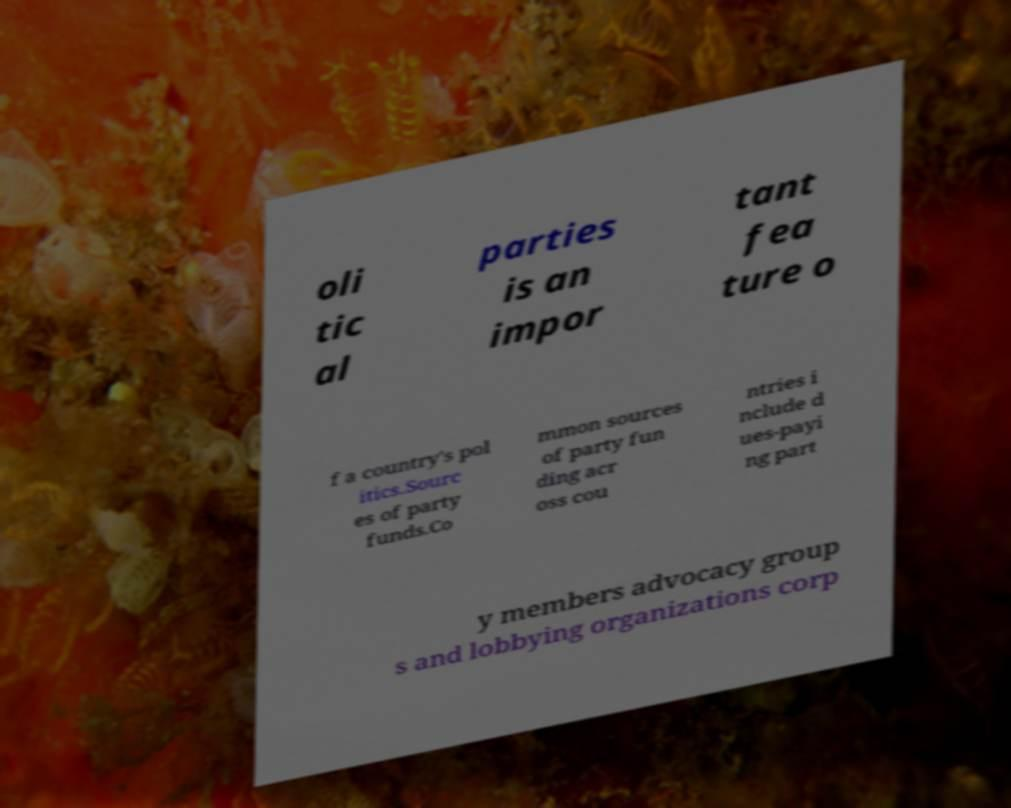Could you assist in decoding the text presented in this image and type it out clearly? oli tic al parties is an impor tant fea ture o f a country's pol itics.Sourc es of party funds.Co mmon sources of party fun ding acr oss cou ntries i nclude d ues-payi ng part y members advocacy group s and lobbying organizations corp 